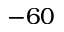Convert formula to latex. <formula><loc_0><loc_0><loc_500><loc_500>- 6 0</formula> 